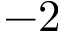<formula> <loc_0><loc_0><loc_500><loc_500>- 2</formula> 